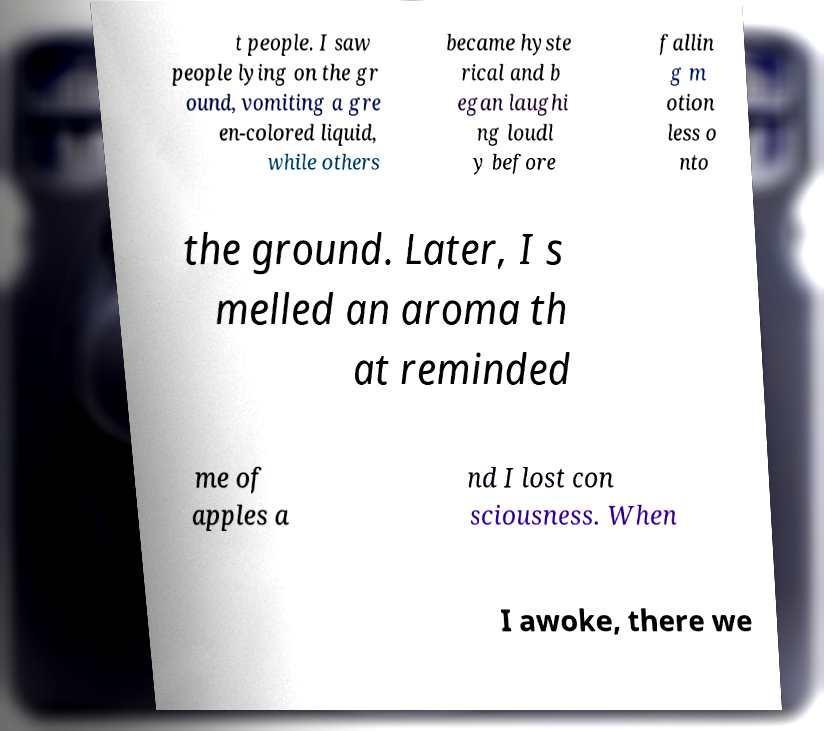I need the written content from this picture converted into text. Can you do that? t people. I saw people lying on the gr ound, vomiting a gre en-colored liquid, while others became hyste rical and b egan laughi ng loudl y before fallin g m otion less o nto the ground. Later, I s melled an aroma th at reminded me of apples a nd I lost con sciousness. When I awoke, there we 